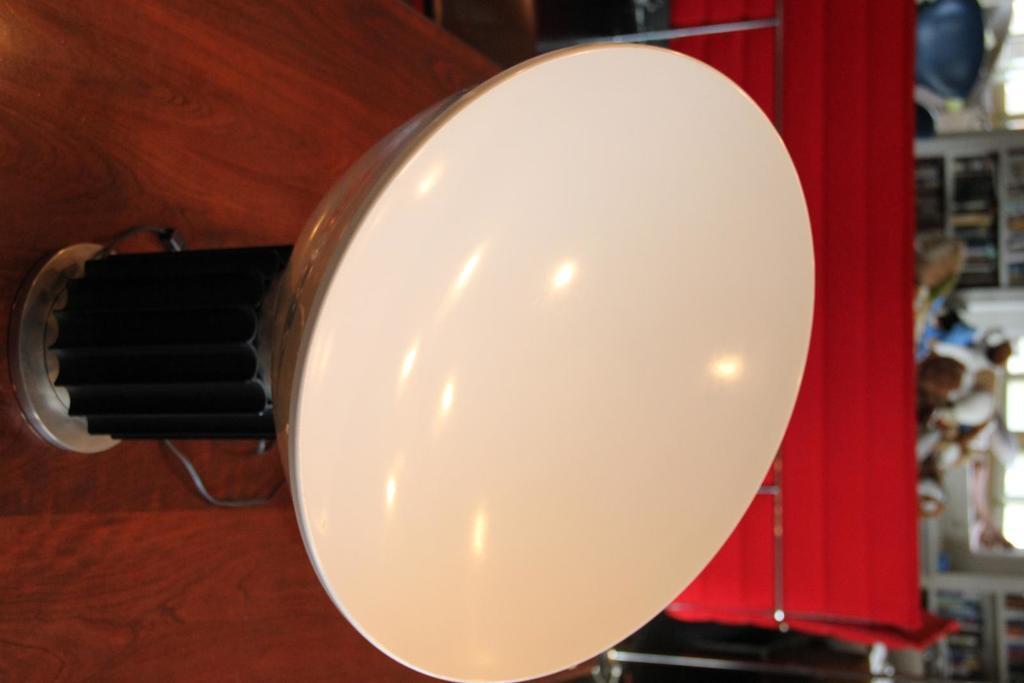In one or two sentences, can you explain what this image depicts? In this picture I can see an object on the table, and in the background there are some objects. 